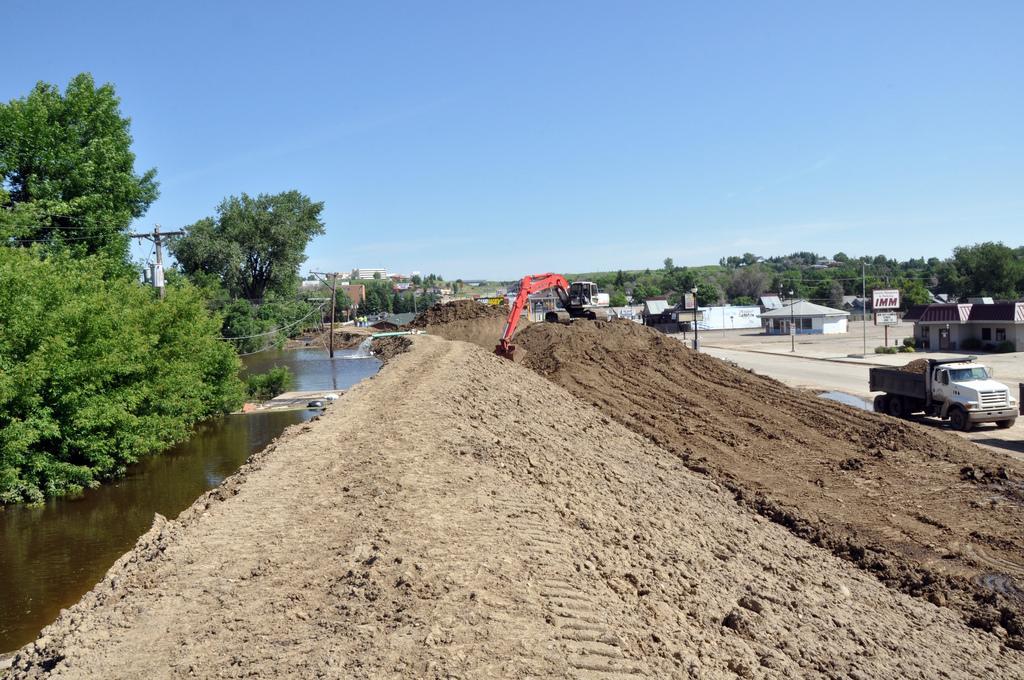In one or two sentences, can you explain what this image depicts? This is the small water canal on left to the canal we can see some trees and right to it we can see a crane lifting sand and right to the crane we can see the bunch of trees,next to them we can see a couple of houses and then we can see a truck carrying sand in it. 